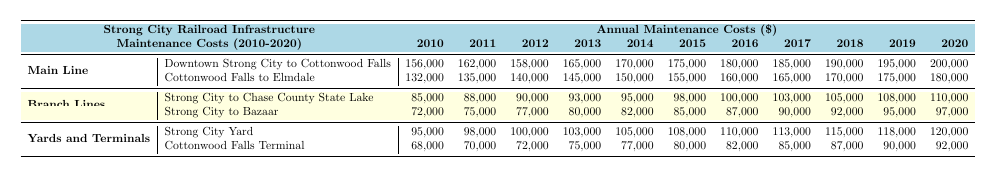What were the annual maintenance costs for the Main Line in 2014? In the table, under the Main Line section, the row for "Downtown Strong City to Cottonwood Falls" shows a cost of 170,000, and "Cottonwood Falls to Elmdale" shows a cost of 150,000 for the year 2014.
Answer: 320,000 Which subsection had the highest maintenance cost in 2020? In the table, looking at the costs for 2020 across all subsections, "Downtown Strong City to Cottonwood Falls" has the highest cost at 200,000.
Answer: Downtown Strong City to Cottonwood Falls What was the percentage increase in maintenance costs from 2010 to 2020 for the Strong City Yard? For Strong City Yard, in 2010 the cost was 95,000, and in 2020 it was 120,000. The increase is 120,000 - 95,000 = 25,000. To find the percentage increase, divide by the original amount: (25,000 / 95,000) * 100 ≈ 26.32%.
Answer: 26.32% What is the total maintenance cost for all subsections in 2013? In 2013, the costs for each subsection are: Downtown Strong City to Cottonwood Falls (165,000), Cottonwood Falls to Elmdale (145,000), Strong City to Chase County State Lake (93,000), Strong City to Bazaar (80,000), Strong City Yard (103,000), and Cottonwood Falls Terminal (75,000). Adding all these: 165,000 + 145,000 + 93,000 + 80,000 + 103,000 + 75,000 = 661,000.
Answer: 661,000 What year saw the lowest maintenance cost for the Strong City to Bazaar line? Looking at the table, the costs for the Strong City to Bazaar line each year are detailed. The lowest cost is in 2010 at 72,000.
Answer: 72,000 Did the maintenance costs for the Cottonwood Falls Terminal increase every year from 2010 to 2020? By examining the table, all annual costs from 2010 (68,000) to 2020 (92,000) for Cottonwood Falls Terminal are found to be increasing without any reductions in the values.
Answer: Yes Which section had the largest total maintenance cost over the entire period from 2010 to 2020? To determine this, calculate the total for each section. For Main Line, it is 1,843,000; for Branch Lines, it is 1,084,000; and for Yards and Terminals, it is 1,184,000. The Main Line has the highest total over the years, indicating it had the largest maintenance cost.
Answer: Main Line What was the average annual maintenance cost for the Cottonwood Falls to Elmdale line from 2010 to 2020? To find the average, sum the annual costs for Cottonwood Falls to Elmdale over the years: 132,000 + 135,000 + 140,000 + 145,000 + 150,000 + 155,000 + 160,000 + 165,000 + 170,000 + 175,000 + 180,000 = 1,707,000. Then, dividing by the number of years (11): 1,707,000 / 11 ≈ 155,182.
Answer: 155,182 Which year had the highest overall maintenance costs among all subsections combined? By analyzing the total cost for each year by adding the maintenance costs of all subsections for that year, it can be observed that 2020 had the highest total costs which equals 1,475,000.
Answer: 2020 What was the cost difference between the least and most expensive section in 2015? In 2015, the most expensive section was the Main Line (175,000 for Downtown to Cottonwood and 155,000 for Cottonwood to Elmdale, totaling 330,000), and the least expensive was Strong City to Bazaar (85,000). The difference between the two is 330,000 - 85,000 = 245,000.
Answer: 245,000 